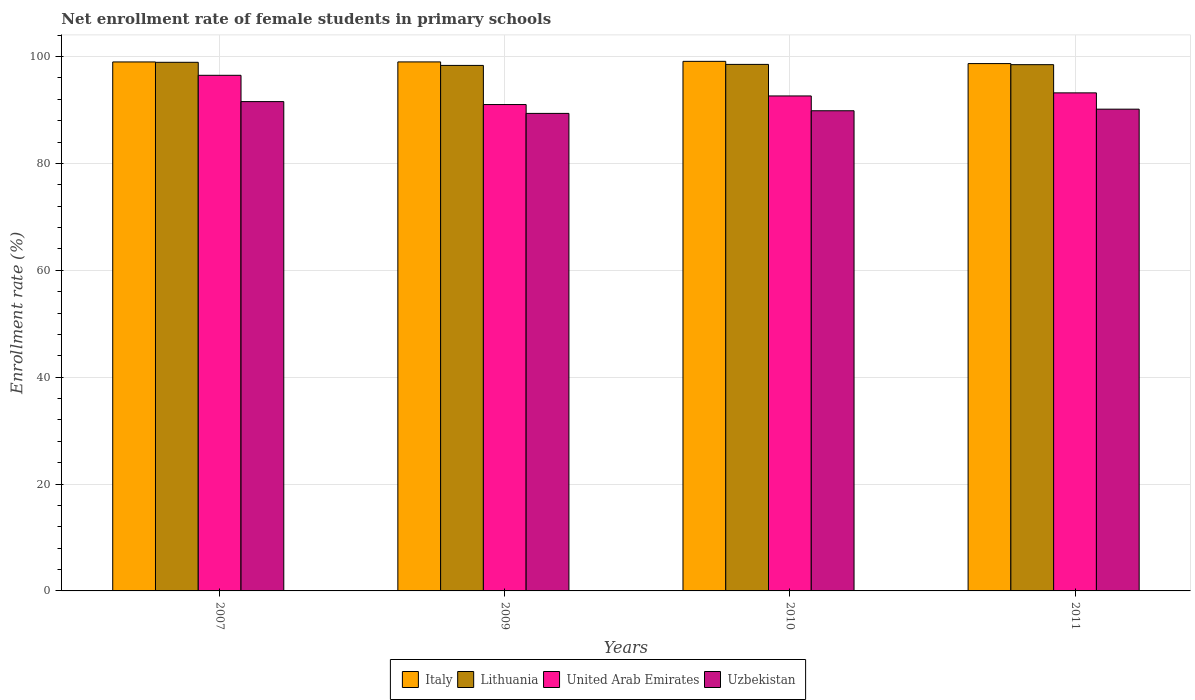Are the number of bars per tick equal to the number of legend labels?
Provide a short and direct response. Yes. Are the number of bars on each tick of the X-axis equal?
Offer a terse response. Yes. How many bars are there on the 1st tick from the left?
Offer a terse response. 4. What is the label of the 1st group of bars from the left?
Ensure brevity in your answer.  2007. In how many cases, is the number of bars for a given year not equal to the number of legend labels?
Make the answer very short. 0. What is the net enrollment rate of female students in primary schools in United Arab Emirates in 2009?
Make the answer very short. 91.03. Across all years, what is the maximum net enrollment rate of female students in primary schools in United Arab Emirates?
Your answer should be compact. 96.5. Across all years, what is the minimum net enrollment rate of female students in primary schools in Uzbekistan?
Give a very brief answer. 89.37. In which year was the net enrollment rate of female students in primary schools in Lithuania maximum?
Provide a short and direct response. 2007. What is the total net enrollment rate of female students in primary schools in United Arab Emirates in the graph?
Keep it short and to the point. 373.38. What is the difference between the net enrollment rate of female students in primary schools in Italy in 2010 and that in 2011?
Your response must be concise. 0.42. What is the difference between the net enrollment rate of female students in primary schools in Italy in 2011 and the net enrollment rate of female students in primary schools in Uzbekistan in 2007?
Provide a succinct answer. 7.12. What is the average net enrollment rate of female students in primary schools in Italy per year?
Make the answer very short. 98.96. In the year 2007, what is the difference between the net enrollment rate of female students in primary schools in Lithuania and net enrollment rate of female students in primary schools in United Arab Emirates?
Provide a short and direct response. 2.43. What is the ratio of the net enrollment rate of female students in primary schools in Uzbekistan in 2007 to that in 2009?
Keep it short and to the point. 1.02. Is the net enrollment rate of female students in primary schools in Lithuania in 2009 less than that in 2010?
Your response must be concise. Yes. What is the difference between the highest and the second highest net enrollment rate of female students in primary schools in Uzbekistan?
Make the answer very short. 1.41. What is the difference between the highest and the lowest net enrollment rate of female students in primary schools in Lithuania?
Give a very brief answer. 0.58. In how many years, is the net enrollment rate of female students in primary schools in Uzbekistan greater than the average net enrollment rate of female students in primary schools in Uzbekistan taken over all years?
Keep it short and to the point. 1. Is it the case that in every year, the sum of the net enrollment rate of female students in primary schools in Italy and net enrollment rate of female students in primary schools in Uzbekistan is greater than the sum of net enrollment rate of female students in primary schools in United Arab Emirates and net enrollment rate of female students in primary schools in Lithuania?
Your answer should be very brief. Yes. What does the 3rd bar from the left in 2010 represents?
Provide a short and direct response. United Arab Emirates. What does the 3rd bar from the right in 2007 represents?
Give a very brief answer. Lithuania. Is it the case that in every year, the sum of the net enrollment rate of female students in primary schools in Uzbekistan and net enrollment rate of female students in primary schools in United Arab Emirates is greater than the net enrollment rate of female students in primary schools in Lithuania?
Your answer should be very brief. Yes. How many bars are there?
Your answer should be compact. 16. Are all the bars in the graph horizontal?
Make the answer very short. No. Are the values on the major ticks of Y-axis written in scientific E-notation?
Your response must be concise. No. Does the graph contain grids?
Your response must be concise. Yes. What is the title of the graph?
Give a very brief answer. Net enrollment rate of female students in primary schools. What is the label or title of the X-axis?
Your answer should be compact. Years. What is the label or title of the Y-axis?
Make the answer very short. Enrollment rate (%). What is the Enrollment rate (%) in Italy in 2007?
Offer a very short reply. 99. What is the Enrollment rate (%) in Lithuania in 2007?
Give a very brief answer. 98.94. What is the Enrollment rate (%) in United Arab Emirates in 2007?
Keep it short and to the point. 96.5. What is the Enrollment rate (%) of Uzbekistan in 2007?
Provide a short and direct response. 91.58. What is the Enrollment rate (%) of Italy in 2009?
Provide a short and direct response. 99.01. What is the Enrollment rate (%) of Lithuania in 2009?
Keep it short and to the point. 98.35. What is the Enrollment rate (%) of United Arab Emirates in 2009?
Provide a succinct answer. 91.03. What is the Enrollment rate (%) of Uzbekistan in 2009?
Offer a very short reply. 89.37. What is the Enrollment rate (%) of Italy in 2010?
Your response must be concise. 99.11. What is the Enrollment rate (%) in Lithuania in 2010?
Provide a succinct answer. 98.54. What is the Enrollment rate (%) of United Arab Emirates in 2010?
Your answer should be very brief. 92.64. What is the Enrollment rate (%) in Uzbekistan in 2010?
Give a very brief answer. 89.87. What is the Enrollment rate (%) of Italy in 2011?
Your response must be concise. 98.7. What is the Enrollment rate (%) in Lithuania in 2011?
Keep it short and to the point. 98.49. What is the Enrollment rate (%) of United Arab Emirates in 2011?
Make the answer very short. 93.21. What is the Enrollment rate (%) in Uzbekistan in 2011?
Provide a succinct answer. 90.17. Across all years, what is the maximum Enrollment rate (%) of Italy?
Your answer should be compact. 99.11. Across all years, what is the maximum Enrollment rate (%) of Lithuania?
Your response must be concise. 98.94. Across all years, what is the maximum Enrollment rate (%) in United Arab Emirates?
Make the answer very short. 96.5. Across all years, what is the maximum Enrollment rate (%) of Uzbekistan?
Make the answer very short. 91.58. Across all years, what is the minimum Enrollment rate (%) in Italy?
Your answer should be compact. 98.7. Across all years, what is the minimum Enrollment rate (%) of Lithuania?
Provide a succinct answer. 98.35. Across all years, what is the minimum Enrollment rate (%) in United Arab Emirates?
Your answer should be very brief. 91.03. Across all years, what is the minimum Enrollment rate (%) in Uzbekistan?
Ensure brevity in your answer.  89.37. What is the total Enrollment rate (%) in Italy in the graph?
Provide a short and direct response. 395.82. What is the total Enrollment rate (%) of Lithuania in the graph?
Make the answer very short. 394.33. What is the total Enrollment rate (%) of United Arab Emirates in the graph?
Ensure brevity in your answer.  373.38. What is the total Enrollment rate (%) of Uzbekistan in the graph?
Keep it short and to the point. 360.99. What is the difference between the Enrollment rate (%) in Italy in 2007 and that in 2009?
Ensure brevity in your answer.  -0. What is the difference between the Enrollment rate (%) in Lithuania in 2007 and that in 2009?
Ensure brevity in your answer.  0.58. What is the difference between the Enrollment rate (%) in United Arab Emirates in 2007 and that in 2009?
Keep it short and to the point. 5.48. What is the difference between the Enrollment rate (%) in Uzbekistan in 2007 and that in 2009?
Your response must be concise. 2.21. What is the difference between the Enrollment rate (%) in Italy in 2007 and that in 2010?
Make the answer very short. -0.11. What is the difference between the Enrollment rate (%) in Lithuania in 2007 and that in 2010?
Offer a very short reply. 0.39. What is the difference between the Enrollment rate (%) in United Arab Emirates in 2007 and that in 2010?
Keep it short and to the point. 3.87. What is the difference between the Enrollment rate (%) in Uzbekistan in 2007 and that in 2010?
Provide a succinct answer. 1.71. What is the difference between the Enrollment rate (%) in Italy in 2007 and that in 2011?
Your answer should be very brief. 0.31. What is the difference between the Enrollment rate (%) of Lithuania in 2007 and that in 2011?
Give a very brief answer. 0.44. What is the difference between the Enrollment rate (%) of United Arab Emirates in 2007 and that in 2011?
Provide a short and direct response. 3.29. What is the difference between the Enrollment rate (%) in Uzbekistan in 2007 and that in 2011?
Offer a very short reply. 1.41. What is the difference between the Enrollment rate (%) of Italy in 2009 and that in 2010?
Keep it short and to the point. -0.11. What is the difference between the Enrollment rate (%) in Lithuania in 2009 and that in 2010?
Ensure brevity in your answer.  -0.19. What is the difference between the Enrollment rate (%) of United Arab Emirates in 2009 and that in 2010?
Ensure brevity in your answer.  -1.61. What is the difference between the Enrollment rate (%) of Uzbekistan in 2009 and that in 2010?
Give a very brief answer. -0.5. What is the difference between the Enrollment rate (%) in Italy in 2009 and that in 2011?
Provide a short and direct response. 0.31. What is the difference between the Enrollment rate (%) of Lithuania in 2009 and that in 2011?
Make the answer very short. -0.14. What is the difference between the Enrollment rate (%) in United Arab Emirates in 2009 and that in 2011?
Offer a terse response. -2.19. What is the difference between the Enrollment rate (%) of Uzbekistan in 2009 and that in 2011?
Ensure brevity in your answer.  -0.79. What is the difference between the Enrollment rate (%) of Italy in 2010 and that in 2011?
Provide a short and direct response. 0.42. What is the difference between the Enrollment rate (%) of Lithuania in 2010 and that in 2011?
Provide a succinct answer. 0.05. What is the difference between the Enrollment rate (%) of United Arab Emirates in 2010 and that in 2011?
Your response must be concise. -0.58. What is the difference between the Enrollment rate (%) in Uzbekistan in 2010 and that in 2011?
Offer a terse response. -0.3. What is the difference between the Enrollment rate (%) of Italy in 2007 and the Enrollment rate (%) of Lithuania in 2009?
Keep it short and to the point. 0.65. What is the difference between the Enrollment rate (%) of Italy in 2007 and the Enrollment rate (%) of United Arab Emirates in 2009?
Provide a succinct answer. 7.98. What is the difference between the Enrollment rate (%) in Italy in 2007 and the Enrollment rate (%) in Uzbekistan in 2009?
Provide a succinct answer. 9.63. What is the difference between the Enrollment rate (%) in Lithuania in 2007 and the Enrollment rate (%) in United Arab Emirates in 2009?
Offer a terse response. 7.91. What is the difference between the Enrollment rate (%) in Lithuania in 2007 and the Enrollment rate (%) in Uzbekistan in 2009?
Offer a very short reply. 9.56. What is the difference between the Enrollment rate (%) in United Arab Emirates in 2007 and the Enrollment rate (%) in Uzbekistan in 2009?
Make the answer very short. 7.13. What is the difference between the Enrollment rate (%) of Italy in 2007 and the Enrollment rate (%) of Lithuania in 2010?
Offer a terse response. 0.46. What is the difference between the Enrollment rate (%) in Italy in 2007 and the Enrollment rate (%) in United Arab Emirates in 2010?
Your answer should be very brief. 6.37. What is the difference between the Enrollment rate (%) of Italy in 2007 and the Enrollment rate (%) of Uzbekistan in 2010?
Ensure brevity in your answer.  9.14. What is the difference between the Enrollment rate (%) in Lithuania in 2007 and the Enrollment rate (%) in United Arab Emirates in 2010?
Provide a succinct answer. 6.3. What is the difference between the Enrollment rate (%) of Lithuania in 2007 and the Enrollment rate (%) of Uzbekistan in 2010?
Your answer should be compact. 9.07. What is the difference between the Enrollment rate (%) of United Arab Emirates in 2007 and the Enrollment rate (%) of Uzbekistan in 2010?
Provide a succinct answer. 6.63. What is the difference between the Enrollment rate (%) in Italy in 2007 and the Enrollment rate (%) in Lithuania in 2011?
Give a very brief answer. 0.51. What is the difference between the Enrollment rate (%) of Italy in 2007 and the Enrollment rate (%) of United Arab Emirates in 2011?
Provide a short and direct response. 5.79. What is the difference between the Enrollment rate (%) of Italy in 2007 and the Enrollment rate (%) of Uzbekistan in 2011?
Provide a succinct answer. 8.84. What is the difference between the Enrollment rate (%) of Lithuania in 2007 and the Enrollment rate (%) of United Arab Emirates in 2011?
Your answer should be very brief. 5.72. What is the difference between the Enrollment rate (%) of Lithuania in 2007 and the Enrollment rate (%) of Uzbekistan in 2011?
Offer a terse response. 8.77. What is the difference between the Enrollment rate (%) of United Arab Emirates in 2007 and the Enrollment rate (%) of Uzbekistan in 2011?
Provide a succinct answer. 6.34. What is the difference between the Enrollment rate (%) of Italy in 2009 and the Enrollment rate (%) of Lithuania in 2010?
Offer a terse response. 0.47. What is the difference between the Enrollment rate (%) in Italy in 2009 and the Enrollment rate (%) in United Arab Emirates in 2010?
Your answer should be compact. 6.37. What is the difference between the Enrollment rate (%) in Italy in 2009 and the Enrollment rate (%) in Uzbekistan in 2010?
Give a very brief answer. 9.14. What is the difference between the Enrollment rate (%) of Lithuania in 2009 and the Enrollment rate (%) of United Arab Emirates in 2010?
Ensure brevity in your answer.  5.71. What is the difference between the Enrollment rate (%) in Lithuania in 2009 and the Enrollment rate (%) in Uzbekistan in 2010?
Provide a succinct answer. 8.48. What is the difference between the Enrollment rate (%) in United Arab Emirates in 2009 and the Enrollment rate (%) in Uzbekistan in 2010?
Your response must be concise. 1.16. What is the difference between the Enrollment rate (%) in Italy in 2009 and the Enrollment rate (%) in Lithuania in 2011?
Provide a succinct answer. 0.52. What is the difference between the Enrollment rate (%) in Italy in 2009 and the Enrollment rate (%) in United Arab Emirates in 2011?
Keep it short and to the point. 5.79. What is the difference between the Enrollment rate (%) in Italy in 2009 and the Enrollment rate (%) in Uzbekistan in 2011?
Provide a short and direct response. 8.84. What is the difference between the Enrollment rate (%) of Lithuania in 2009 and the Enrollment rate (%) of United Arab Emirates in 2011?
Provide a succinct answer. 5.14. What is the difference between the Enrollment rate (%) in Lithuania in 2009 and the Enrollment rate (%) in Uzbekistan in 2011?
Your response must be concise. 8.19. What is the difference between the Enrollment rate (%) of United Arab Emirates in 2009 and the Enrollment rate (%) of Uzbekistan in 2011?
Your response must be concise. 0.86. What is the difference between the Enrollment rate (%) in Italy in 2010 and the Enrollment rate (%) in Lithuania in 2011?
Give a very brief answer. 0.62. What is the difference between the Enrollment rate (%) of Italy in 2010 and the Enrollment rate (%) of United Arab Emirates in 2011?
Your response must be concise. 5.9. What is the difference between the Enrollment rate (%) in Italy in 2010 and the Enrollment rate (%) in Uzbekistan in 2011?
Your response must be concise. 8.95. What is the difference between the Enrollment rate (%) of Lithuania in 2010 and the Enrollment rate (%) of United Arab Emirates in 2011?
Make the answer very short. 5.33. What is the difference between the Enrollment rate (%) of Lithuania in 2010 and the Enrollment rate (%) of Uzbekistan in 2011?
Offer a terse response. 8.38. What is the difference between the Enrollment rate (%) of United Arab Emirates in 2010 and the Enrollment rate (%) of Uzbekistan in 2011?
Keep it short and to the point. 2.47. What is the average Enrollment rate (%) in Italy per year?
Make the answer very short. 98.96. What is the average Enrollment rate (%) in Lithuania per year?
Offer a terse response. 98.58. What is the average Enrollment rate (%) in United Arab Emirates per year?
Make the answer very short. 93.35. What is the average Enrollment rate (%) in Uzbekistan per year?
Your response must be concise. 90.25. In the year 2007, what is the difference between the Enrollment rate (%) of Italy and Enrollment rate (%) of Lithuania?
Provide a short and direct response. 0.07. In the year 2007, what is the difference between the Enrollment rate (%) of Italy and Enrollment rate (%) of United Arab Emirates?
Make the answer very short. 2.5. In the year 2007, what is the difference between the Enrollment rate (%) in Italy and Enrollment rate (%) in Uzbekistan?
Provide a succinct answer. 7.42. In the year 2007, what is the difference between the Enrollment rate (%) in Lithuania and Enrollment rate (%) in United Arab Emirates?
Give a very brief answer. 2.43. In the year 2007, what is the difference between the Enrollment rate (%) of Lithuania and Enrollment rate (%) of Uzbekistan?
Make the answer very short. 7.36. In the year 2007, what is the difference between the Enrollment rate (%) in United Arab Emirates and Enrollment rate (%) in Uzbekistan?
Provide a short and direct response. 4.92. In the year 2009, what is the difference between the Enrollment rate (%) in Italy and Enrollment rate (%) in Lithuania?
Your response must be concise. 0.66. In the year 2009, what is the difference between the Enrollment rate (%) of Italy and Enrollment rate (%) of United Arab Emirates?
Your answer should be very brief. 7.98. In the year 2009, what is the difference between the Enrollment rate (%) in Italy and Enrollment rate (%) in Uzbekistan?
Offer a terse response. 9.64. In the year 2009, what is the difference between the Enrollment rate (%) of Lithuania and Enrollment rate (%) of United Arab Emirates?
Provide a short and direct response. 7.33. In the year 2009, what is the difference between the Enrollment rate (%) of Lithuania and Enrollment rate (%) of Uzbekistan?
Your answer should be very brief. 8.98. In the year 2009, what is the difference between the Enrollment rate (%) of United Arab Emirates and Enrollment rate (%) of Uzbekistan?
Make the answer very short. 1.66. In the year 2010, what is the difference between the Enrollment rate (%) in Italy and Enrollment rate (%) in Lithuania?
Your response must be concise. 0.57. In the year 2010, what is the difference between the Enrollment rate (%) in Italy and Enrollment rate (%) in United Arab Emirates?
Your response must be concise. 6.48. In the year 2010, what is the difference between the Enrollment rate (%) in Italy and Enrollment rate (%) in Uzbekistan?
Offer a very short reply. 9.25. In the year 2010, what is the difference between the Enrollment rate (%) of Lithuania and Enrollment rate (%) of United Arab Emirates?
Offer a very short reply. 5.9. In the year 2010, what is the difference between the Enrollment rate (%) of Lithuania and Enrollment rate (%) of Uzbekistan?
Keep it short and to the point. 8.67. In the year 2010, what is the difference between the Enrollment rate (%) of United Arab Emirates and Enrollment rate (%) of Uzbekistan?
Make the answer very short. 2.77. In the year 2011, what is the difference between the Enrollment rate (%) of Italy and Enrollment rate (%) of Lithuania?
Your response must be concise. 0.2. In the year 2011, what is the difference between the Enrollment rate (%) in Italy and Enrollment rate (%) in United Arab Emirates?
Your response must be concise. 5.48. In the year 2011, what is the difference between the Enrollment rate (%) of Italy and Enrollment rate (%) of Uzbekistan?
Your answer should be compact. 8.53. In the year 2011, what is the difference between the Enrollment rate (%) in Lithuania and Enrollment rate (%) in United Arab Emirates?
Provide a succinct answer. 5.28. In the year 2011, what is the difference between the Enrollment rate (%) of Lithuania and Enrollment rate (%) of Uzbekistan?
Offer a very short reply. 8.33. In the year 2011, what is the difference between the Enrollment rate (%) of United Arab Emirates and Enrollment rate (%) of Uzbekistan?
Keep it short and to the point. 3.05. What is the ratio of the Enrollment rate (%) in Italy in 2007 to that in 2009?
Give a very brief answer. 1. What is the ratio of the Enrollment rate (%) of Lithuania in 2007 to that in 2009?
Offer a very short reply. 1.01. What is the ratio of the Enrollment rate (%) of United Arab Emirates in 2007 to that in 2009?
Make the answer very short. 1.06. What is the ratio of the Enrollment rate (%) in Uzbekistan in 2007 to that in 2009?
Keep it short and to the point. 1.02. What is the ratio of the Enrollment rate (%) of Italy in 2007 to that in 2010?
Offer a very short reply. 1. What is the ratio of the Enrollment rate (%) in United Arab Emirates in 2007 to that in 2010?
Offer a terse response. 1.04. What is the ratio of the Enrollment rate (%) of Uzbekistan in 2007 to that in 2010?
Ensure brevity in your answer.  1.02. What is the ratio of the Enrollment rate (%) in Italy in 2007 to that in 2011?
Offer a terse response. 1. What is the ratio of the Enrollment rate (%) of Lithuania in 2007 to that in 2011?
Offer a terse response. 1. What is the ratio of the Enrollment rate (%) in United Arab Emirates in 2007 to that in 2011?
Provide a succinct answer. 1.04. What is the ratio of the Enrollment rate (%) of Uzbekistan in 2007 to that in 2011?
Offer a terse response. 1.02. What is the ratio of the Enrollment rate (%) of United Arab Emirates in 2009 to that in 2010?
Give a very brief answer. 0.98. What is the ratio of the Enrollment rate (%) of Uzbekistan in 2009 to that in 2010?
Keep it short and to the point. 0.99. What is the ratio of the Enrollment rate (%) in Italy in 2009 to that in 2011?
Provide a succinct answer. 1. What is the ratio of the Enrollment rate (%) in United Arab Emirates in 2009 to that in 2011?
Keep it short and to the point. 0.98. What is the ratio of the Enrollment rate (%) of Lithuania in 2010 to that in 2011?
Ensure brevity in your answer.  1. What is the difference between the highest and the second highest Enrollment rate (%) of Italy?
Make the answer very short. 0.11. What is the difference between the highest and the second highest Enrollment rate (%) of Lithuania?
Make the answer very short. 0.39. What is the difference between the highest and the second highest Enrollment rate (%) in United Arab Emirates?
Provide a short and direct response. 3.29. What is the difference between the highest and the second highest Enrollment rate (%) in Uzbekistan?
Make the answer very short. 1.41. What is the difference between the highest and the lowest Enrollment rate (%) of Italy?
Your response must be concise. 0.42. What is the difference between the highest and the lowest Enrollment rate (%) of Lithuania?
Ensure brevity in your answer.  0.58. What is the difference between the highest and the lowest Enrollment rate (%) of United Arab Emirates?
Keep it short and to the point. 5.48. What is the difference between the highest and the lowest Enrollment rate (%) of Uzbekistan?
Offer a terse response. 2.21. 